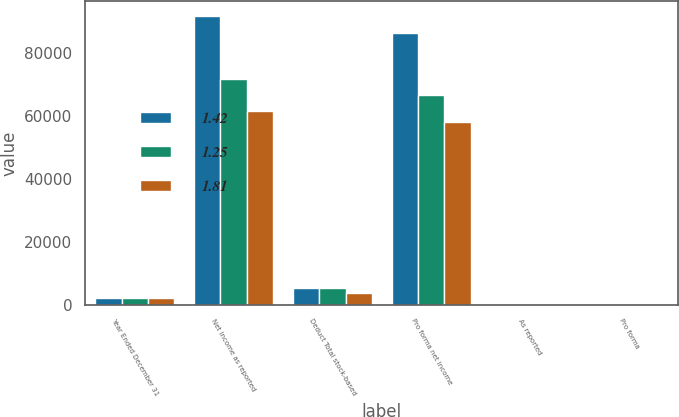Convert chart. <chart><loc_0><loc_0><loc_500><loc_500><stacked_bar_chart><ecel><fcel>Year Ended December 31<fcel>Net income as reported<fcel>Deduct Total stock-based<fcel>Pro forma net income<fcel>As reported<fcel>Pro forma<nl><fcel>1.42<fcel>2003<fcel>91696<fcel>5374<fcel>86322<fcel>1.95<fcel>1.83<nl><fcel>1.25<fcel>2002<fcel>71595<fcel>5102<fcel>66493<fcel>1.54<fcel>1.43<nl><fcel>1.81<fcel>2001<fcel>61529<fcel>3558<fcel>57971<fcel>1.34<fcel>1.26<nl></chart> 